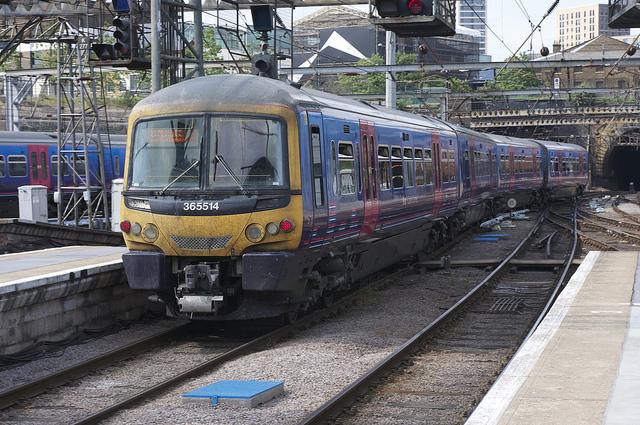Is the train moving?
Keep it brief. No. Do you see a ship?
Short answer required. No. What type of vehicle is this?
Give a very brief answer. Train. 